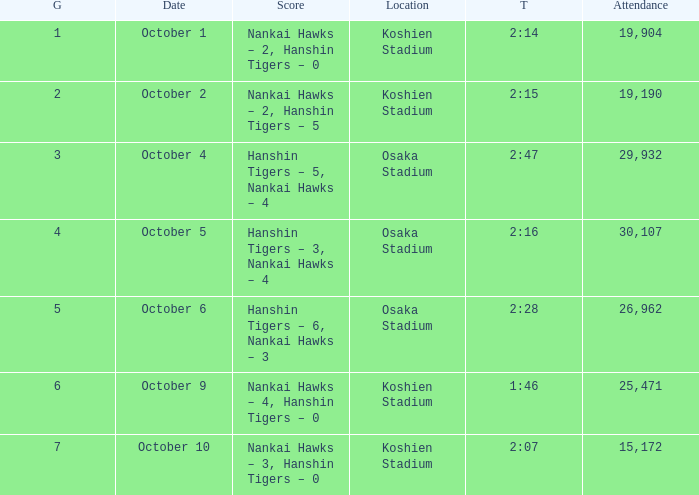Which Score has a Time of 2:28? Hanshin Tigers – 6, Nankai Hawks – 3. 